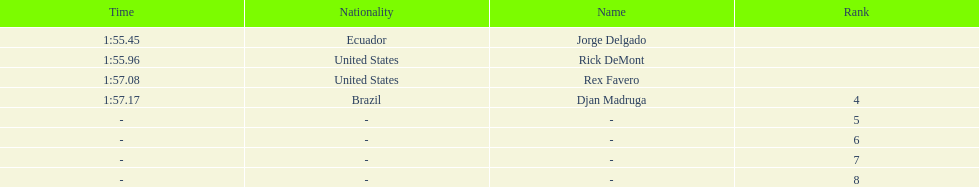Who was the last finisher from the us? Rex Favero. 